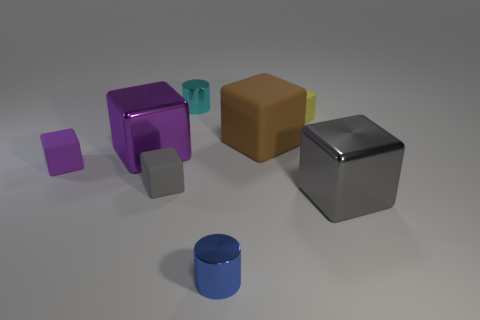Is the tiny cylinder in front of the tiny cyan object made of the same material as the cyan cylinder?
Your response must be concise. Yes. Does the small object that is in front of the small gray object have the same material as the small block that is to the right of the cyan cylinder?
Provide a short and direct response. No. Are there more small purple rubber objects behind the small purple thing than large gray cubes?
Keep it short and to the point. No. What color is the small cylinder that is behind the tiny shiny cylinder in front of the big gray object?
Ensure brevity in your answer.  Cyan. There is a cyan metal thing that is the same size as the blue metal cylinder; what shape is it?
Give a very brief answer. Cylinder. Are there an equal number of cylinders that are to the left of the small yellow object and small cyan metal cylinders?
Provide a short and direct response. No. What material is the small thing in front of the big block in front of the gray cube left of the yellow object?
Offer a very short reply. Metal. What shape is the yellow thing that is made of the same material as the small gray cube?
Provide a short and direct response. Cube. Is there any other thing that has the same color as the large rubber block?
Your answer should be very brief. No. There is a tiny thing in front of the big object that is right of the tiny yellow rubber block; how many blue cylinders are to the right of it?
Ensure brevity in your answer.  0. 